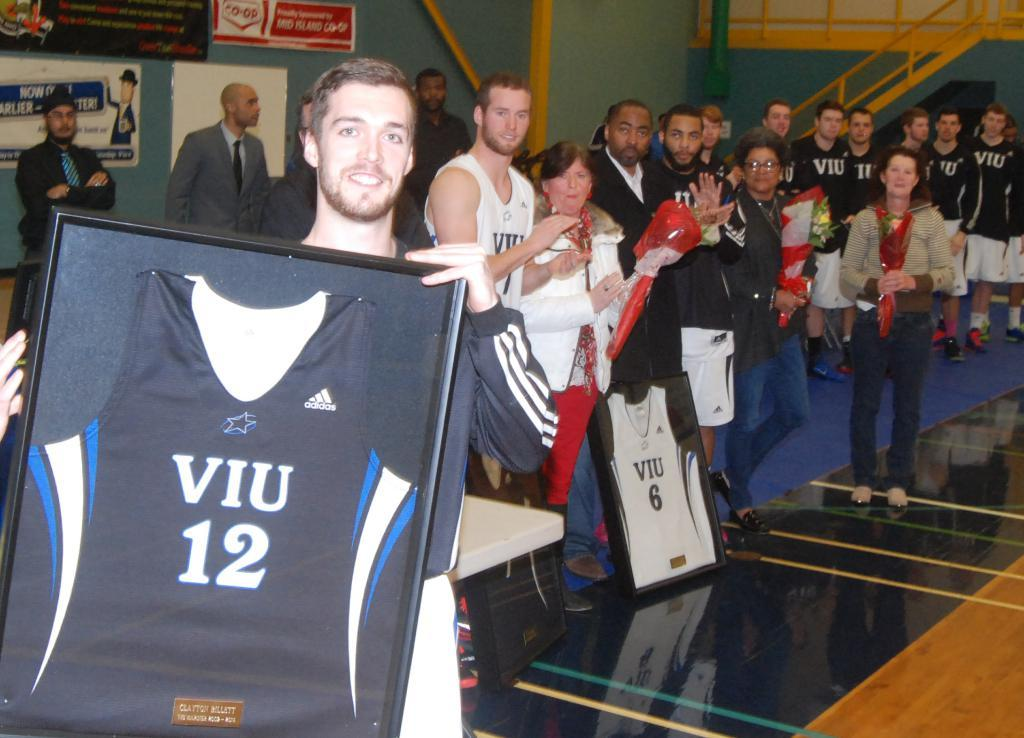<image>
Create a compact narrative representing the image presented. A guy holds up a framed jersey with the number 12 on it. 